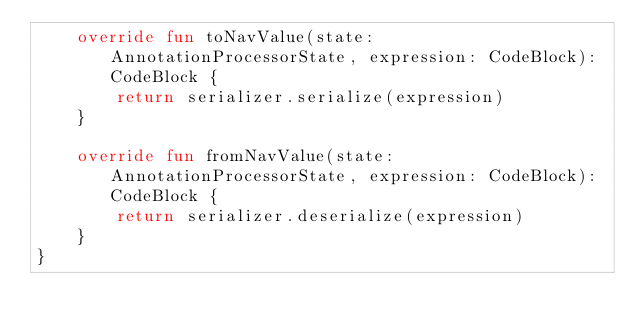Convert code to text. <code><loc_0><loc_0><loc_500><loc_500><_Kotlin_>    override fun toNavValue(state: AnnotationProcessorState, expression: CodeBlock): CodeBlock {
        return serializer.serialize(expression)
    }

    override fun fromNavValue(state: AnnotationProcessorState, expression: CodeBlock): CodeBlock {
        return serializer.deserialize(expression)
    }
}
</code> 